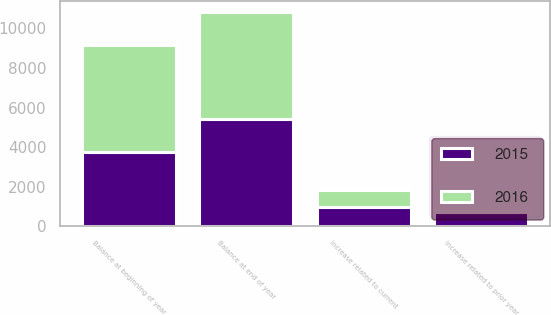<chart> <loc_0><loc_0><loc_500><loc_500><stacked_bar_chart><ecel><fcel>Balance at beginning of year<fcel>Increase related to prior year<fcel>Increase related to current<fcel>Balance at end of year<nl><fcel>2016<fcel>5417<fcel>194<fcel>846<fcel>5407<nl><fcel>2015<fcel>3772<fcel>704<fcel>984<fcel>5417<nl></chart> 